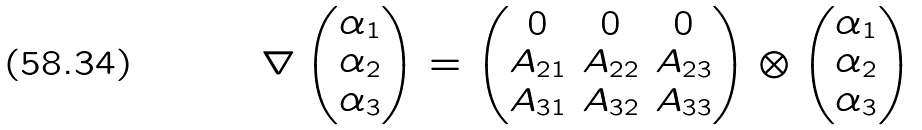<formula> <loc_0><loc_0><loc_500><loc_500>\nabla \left ( \begin{matrix} \alpha _ { 1 } \\ \alpha _ { 2 } \\ \alpha _ { 3 } \end{matrix} \right ) = \left ( \begin{matrix} 0 & 0 & 0 \\ A _ { 2 1 } & A _ { 2 2 } & A _ { 2 3 } \\ A _ { 3 1 } & A _ { 3 2 } & A _ { 3 3 } \end{matrix} \right ) \otimes \left ( \begin{matrix} \alpha _ { 1 } \\ \alpha _ { 2 } \\ \alpha _ { 3 } \end{matrix} \right )</formula> 